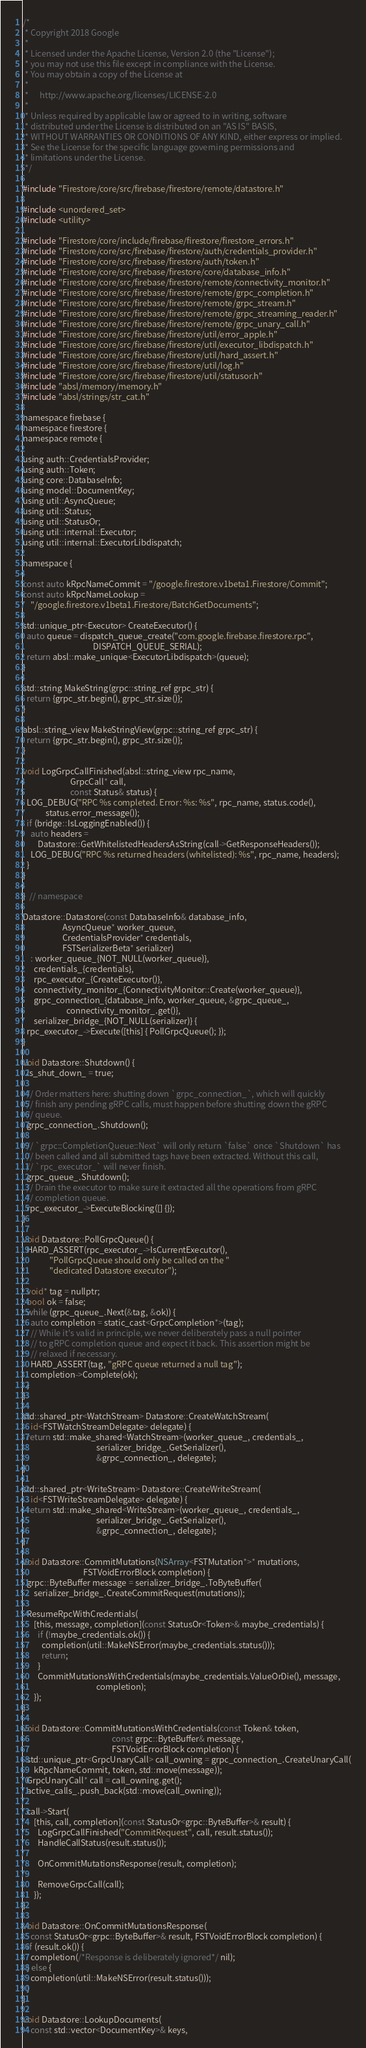<code> <loc_0><loc_0><loc_500><loc_500><_ObjectiveC_>/*
 * Copyright 2018 Google
 *
 * Licensed under the Apache License, Version 2.0 (the "License");
 * you may not use this file except in compliance with the License.
 * You may obtain a copy of the License at
 *
 *      http://www.apache.org/licenses/LICENSE-2.0
 *
 * Unless required by applicable law or agreed to in writing, software
 * distributed under the License is distributed on an "AS IS" BASIS,
 * WITHOUT WARRANTIES OR CONDITIONS OF ANY KIND, either express or implied.
 * See the License for the specific language governing permissions and
 * limitations under the License.
 */

#include "Firestore/core/src/firebase/firestore/remote/datastore.h"

#include <unordered_set>
#include <utility>

#include "Firestore/core/include/firebase/firestore/firestore_errors.h"
#include "Firestore/core/src/firebase/firestore/auth/credentials_provider.h"
#include "Firestore/core/src/firebase/firestore/auth/token.h"
#include "Firestore/core/src/firebase/firestore/core/database_info.h"
#include "Firestore/core/src/firebase/firestore/remote/connectivity_monitor.h"
#include "Firestore/core/src/firebase/firestore/remote/grpc_completion.h"
#include "Firestore/core/src/firebase/firestore/remote/grpc_stream.h"
#include "Firestore/core/src/firebase/firestore/remote/grpc_streaming_reader.h"
#include "Firestore/core/src/firebase/firestore/remote/grpc_unary_call.h"
#include "Firestore/core/src/firebase/firestore/util/error_apple.h"
#include "Firestore/core/src/firebase/firestore/util/executor_libdispatch.h"
#include "Firestore/core/src/firebase/firestore/util/hard_assert.h"
#include "Firestore/core/src/firebase/firestore/util/log.h"
#include "Firestore/core/src/firebase/firestore/util/statusor.h"
#include "absl/memory/memory.h"
#include "absl/strings/str_cat.h"

namespace firebase {
namespace firestore {
namespace remote {

using auth::CredentialsProvider;
using auth::Token;
using core::DatabaseInfo;
using model::DocumentKey;
using util::AsyncQueue;
using util::Status;
using util::StatusOr;
using util::internal::Executor;
using util::internal::ExecutorLibdispatch;

namespace {

const auto kRpcNameCommit = "/google.firestore.v1beta1.Firestore/Commit";
const auto kRpcNameLookup =
    "/google.firestore.v1beta1.Firestore/BatchGetDocuments";

std::unique_ptr<Executor> CreateExecutor() {
  auto queue = dispatch_queue_create("com.google.firebase.firestore.rpc",
                                     DISPATCH_QUEUE_SERIAL);
  return absl::make_unique<ExecutorLibdispatch>(queue);
}

std::string MakeString(grpc::string_ref grpc_str) {
  return {grpc_str.begin(), grpc_str.size()};
}

absl::string_view MakeStringView(grpc::string_ref grpc_str) {
  return {grpc_str.begin(), grpc_str.size()};
}

void LogGrpcCallFinished(absl::string_view rpc_name,
                         GrpcCall* call,
                         const Status& status) {
  LOG_DEBUG("RPC %s completed. Error: %s: %s", rpc_name, status.code(),
            status.error_message());
  if (bridge::IsLoggingEnabled()) {
    auto headers =
        Datastore::GetWhitelistedHeadersAsString(call->GetResponseHeaders());
    LOG_DEBUG("RPC %s returned headers (whitelisted): %s", rpc_name, headers);
  }
}

}  // namespace

Datastore::Datastore(const DatabaseInfo& database_info,
                     AsyncQueue* worker_queue,
                     CredentialsProvider* credentials,
                     FSTSerializerBeta* serializer)
    : worker_queue_{NOT_NULL(worker_queue)},
      credentials_{credentials},
      rpc_executor_{CreateExecutor()},
      connectivity_monitor_{ConnectivityMonitor::Create(worker_queue)},
      grpc_connection_{database_info, worker_queue, &grpc_queue_,
                       connectivity_monitor_.get()},
      serializer_bridge_{NOT_NULL(serializer)} {
  rpc_executor_->Execute([this] { PollGrpcQueue(); });
}

void Datastore::Shutdown() {
  is_shut_down_ = true;

  // Order matters here: shutting down `grpc_connection_`, which will quickly
  // finish any pending gRPC calls, must happen before shutting down the gRPC
  // queue.
  grpc_connection_.Shutdown();

  // `grpc::CompletionQueue::Next` will only return `false` once `Shutdown` has
  // been called and all submitted tags have been extracted. Without this call,
  // `rpc_executor_` will never finish.
  grpc_queue_.Shutdown();
  // Drain the executor to make sure it extracted all the operations from gRPC
  // completion queue.
  rpc_executor_->ExecuteBlocking([] {});
}

void Datastore::PollGrpcQueue() {
  HARD_ASSERT(rpc_executor_->IsCurrentExecutor(),
              "PollGrpcQueue should only be called on the "
              "dedicated Datastore executor");

  void* tag = nullptr;
  bool ok = false;
  while (grpc_queue_.Next(&tag, &ok)) {
    auto completion = static_cast<GrpcCompletion*>(tag);
    // While it's valid in principle, we never deliberately pass a null pointer
    // to gRPC completion queue and expect it back. This assertion might be
    // relaxed if necessary.
    HARD_ASSERT(tag, "gRPC queue returned a null tag");
    completion->Complete(ok);
  }
}

std::shared_ptr<WatchStream> Datastore::CreateWatchStream(
    id<FSTWatchStreamDelegate> delegate) {
  return std::make_shared<WatchStream>(worker_queue_, credentials_,
                                       serializer_bridge_.GetSerializer(),
                                       &grpc_connection_, delegate);
}

std::shared_ptr<WriteStream> Datastore::CreateWriteStream(
    id<FSTWriteStreamDelegate> delegate) {
  return std::make_shared<WriteStream>(worker_queue_, credentials_,
                                       serializer_bridge_.GetSerializer(),
                                       &grpc_connection_, delegate);
}

void Datastore::CommitMutations(NSArray<FSTMutation*>* mutations,
                                FSTVoidErrorBlock completion) {
  grpc::ByteBuffer message = serializer_bridge_.ToByteBuffer(
      serializer_bridge_.CreateCommitRequest(mutations));

  ResumeRpcWithCredentials(
      [this, message, completion](const StatusOr<Token>& maybe_credentials) {
        if (!maybe_credentials.ok()) {
          completion(util::MakeNSError(maybe_credentials.status()));
          return;
        }
        CommitMutationsWithCredentials(maybe_credentials.ValueOrDie(), message,
                                       completion);
      });
}

void Datastore::CommitMutationsWithCredentials(const Token& token,
                                               const grpc::ByteBuffer& message,
                                               FSTVoidErrorBlock completion) {
  std::unique_ptr<GrpcUnaryCall> call_owning = grpc_connection_.CreateUnaryCall(
      kRpcNameCommit, token, std::move(message));
  GrpcUnaryCall* call = call_owning.get();
  active_calls_.push_back(std::move(call_owning));

  call->Start(
      [this, call, completion](const StatusOr<grpc::ByteBuffer>& result) {
        LogGrpcCallFinished("CommitRequest", call, result.status());
        HandleCallStatus(result.status());

        OnCommitMutationsResponse(result, completion);

        RemoveGrpcCall(call);
      });
}

void Datastore::OnCommitMutationsResponse(
    const StatusOr<grpc::ByteBuffer>& result, FSTVoidErrorBlock completion) {
  if (result.ok()) {
    completion(/*Response is deliberately ignored*/ nil);
  } else {
    completion(util::MakeNSError(result.status()));
  }
}

void Datastore::LookupDocuments(
    const std::vector<DocumentKey>& keys,</code> 